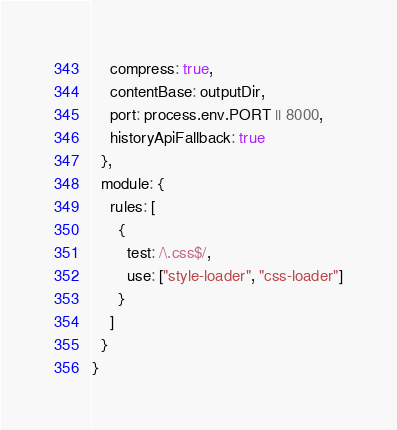<code> <loc_0><loc_0><loc_500><loc_500><_JavaScript_>    compress: true,
    contentBase: outputDir,
    port: process.env.PORT || 8000,
    historyApiFallback: true
  },
  module: {
    rules: [
      {
        test: /\.css$/,
        use: ["style-loader", "css-loader"]
      }
    ]
  }
}
</code> 